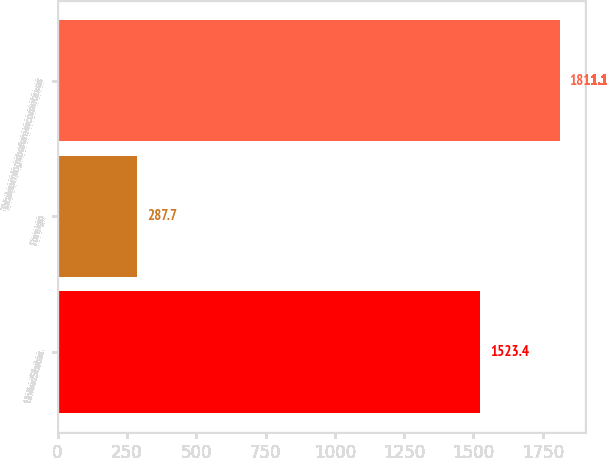<chart> <loc_0><loc_0><loc_500><loc_500><bar_chart><fcel>UnitedStates<fcel>Foreign<fcel>Totalearningsbeforeincometaxes<nl><fcel>1523.4<fcel>287.7<fcel>1811.1<nl></chart> 